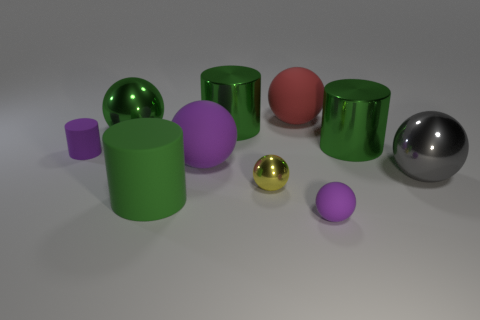How many big rubber things are the same color as the tiny rubber ball?
Provide a short and direct response. 1. There is a green cylinder that is on the right side of the red sphere; what material is it?
Keep it short and to the point. Metal. Are there the same number of red matte balls in front of the gray metallic thing and brown cubes?
Provide a short and direct response. Yes. Does the yellow ball have the same size as the gray metal sphere?
Your answer should be very brief. No. There is a big green cylinder behind the big green metallic object in front of the large green metal sphere; is there a big green sphere that is in front of it?
Your answer should be very brief. Yes. What material is the big red thing that is the same shape as the large gray object?
Your answer should be very brief. Rubber. There is a tiny rubber thing on the left side of the large purple rubber ball; what number of tiny matte things are behind it?
Your answer should be very brief. 0. There is a metal sphere that is in front of the large metal sphere that is in front of the thing to the left of the large green shiny sphere; what is its size?
Keep it short and to the point. Small. There is a cylinder in front of the large metal sphere to the right of the large rubber cylinder; what color is it?
Offer a very short reply. Green. What number of other objects are the same color as the tiny cylinder?
Offer a terse response. 2. 